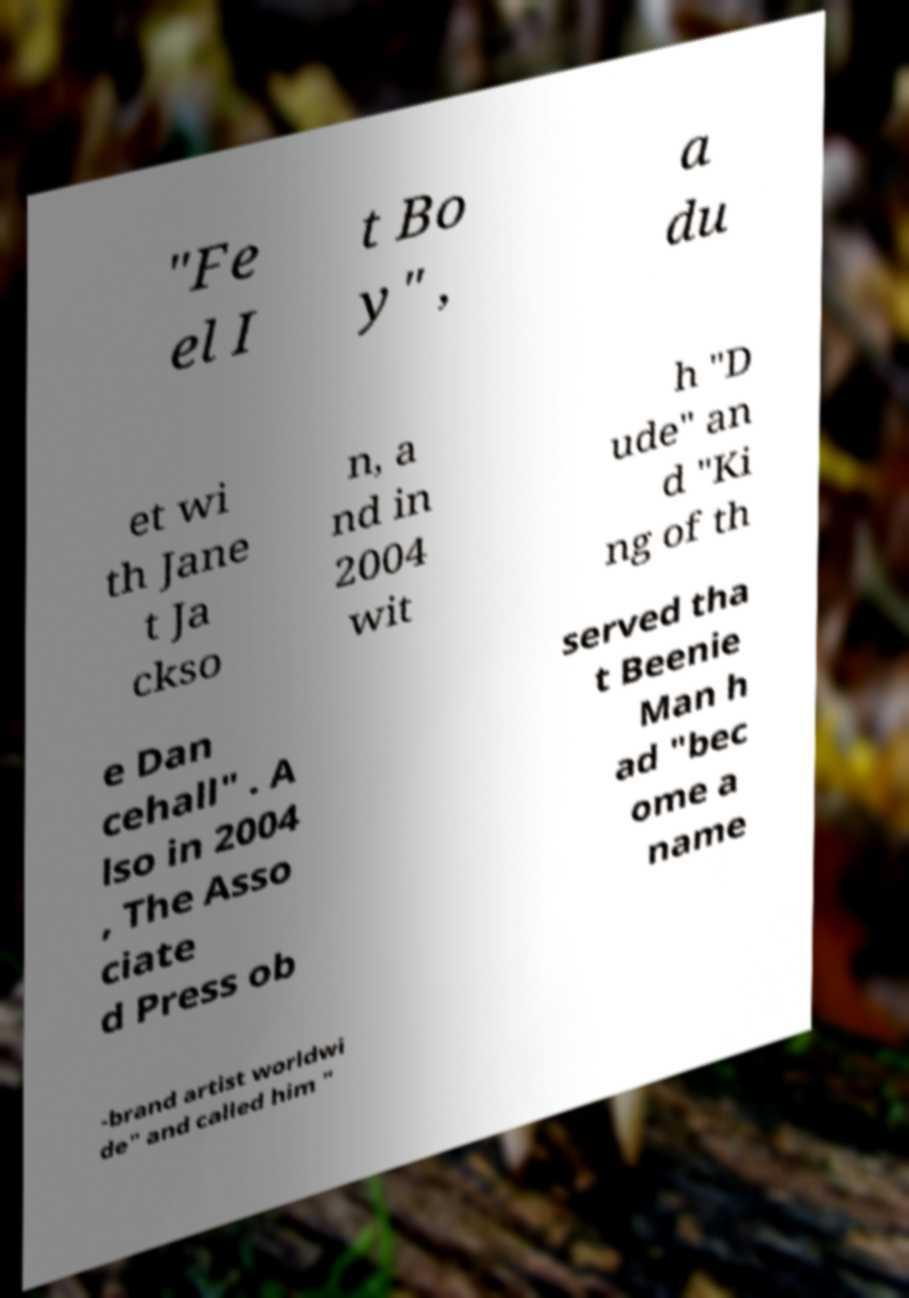There's text embedded in this image that I need extracted. Can you transcribe it verbatim? "Fe el I t Bo y" , a du et wi th Jane t Ja ckso n, a nd in 2004 wit h "D ude" an d "Ki ng of th e Dan cehall" . A lso in 2004 , The Asso ciate d Press ob served tha t Beenie Man h ad "bec ome a name -brand artist worldwi de" and called him " 